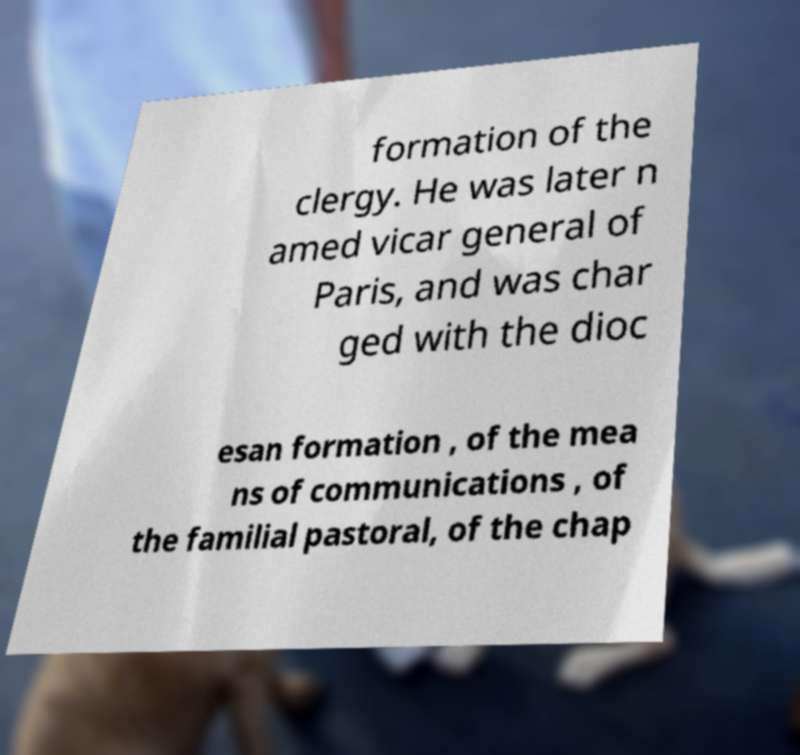There's text embedded in this image that I need extracted. Can you transcribe it verbatim? formation of the clergy. He was later n amed vicar general of Paris, and was char ged with the dioc esan formation , of the mea ns of communications , of the familial pastoral, of the chap 